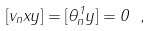Convert formula to latex. <formula><loc_0><loc_0><loc_500><loc_500>[ v _ { n } x y ] = [ \theta _ { n } ^ { 1 } y ] = 0 \ ,</formula> 